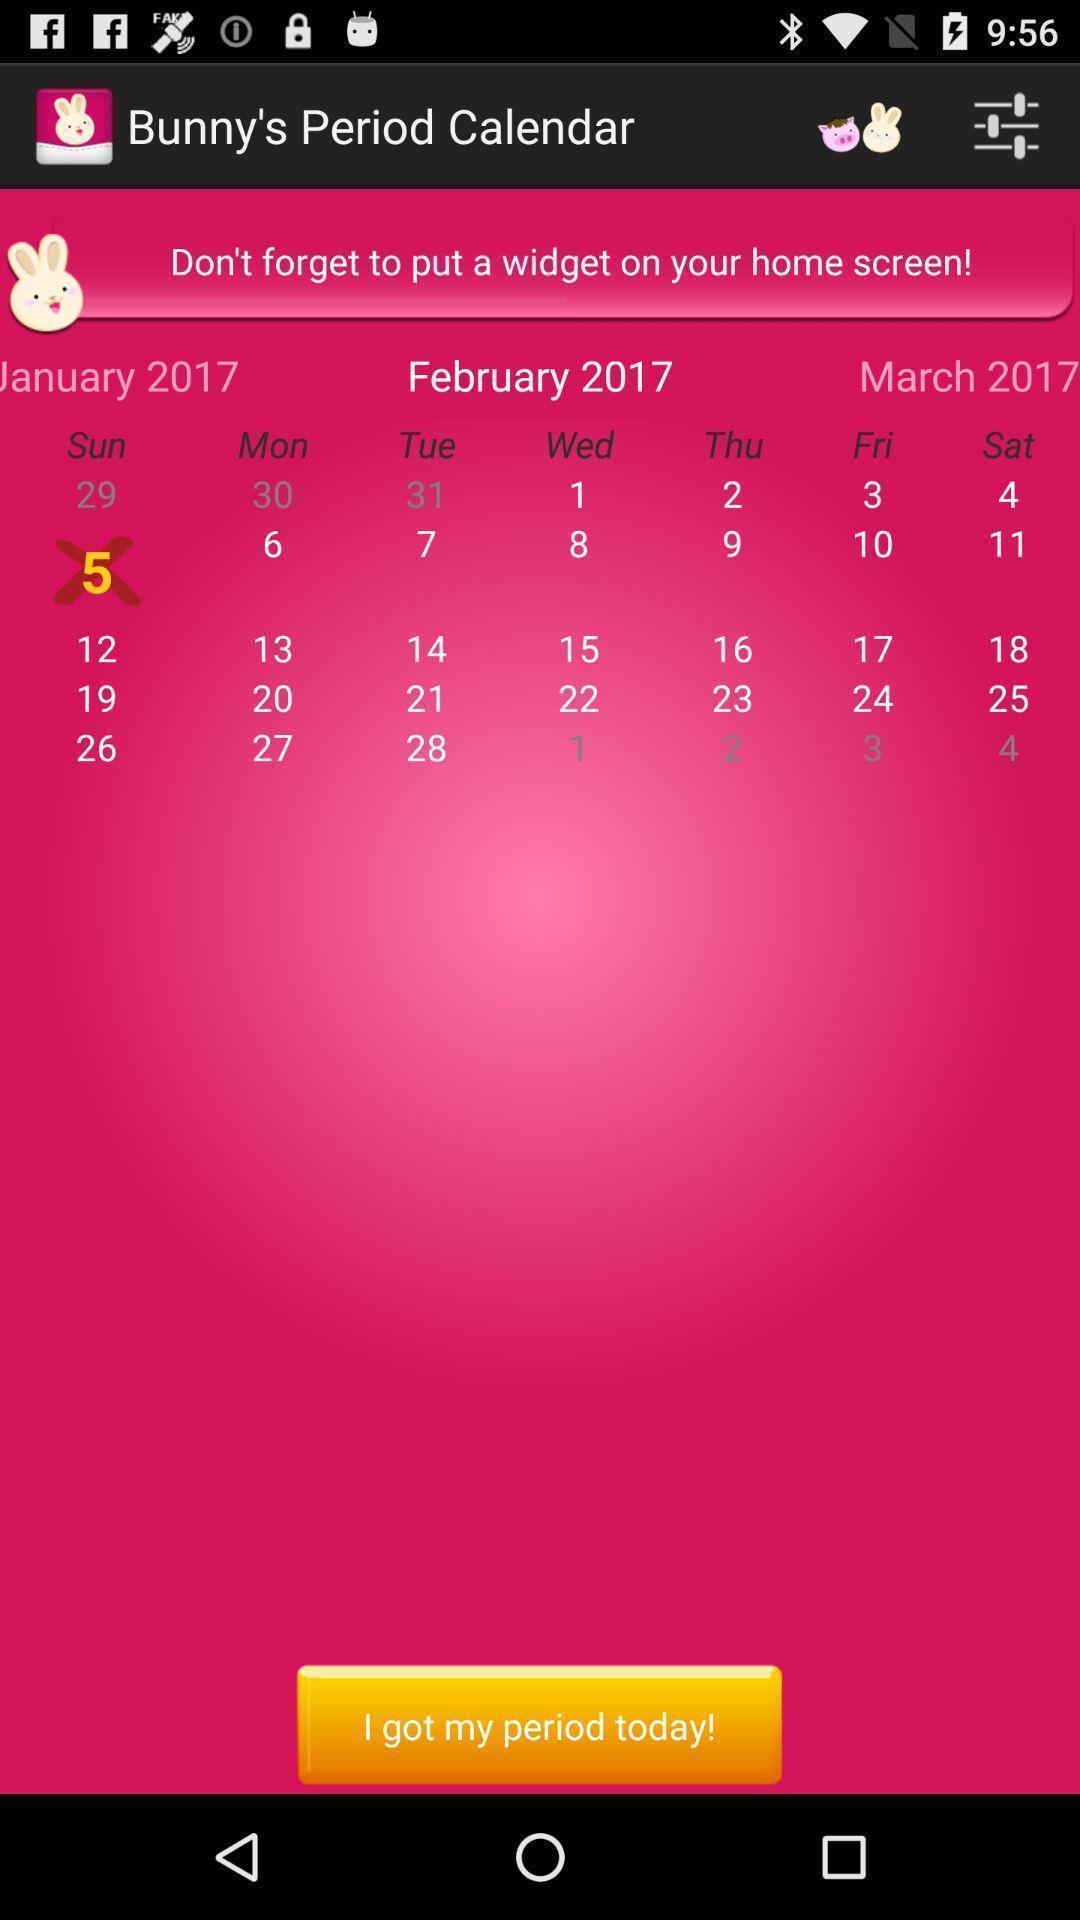Summarize the main components in this picture. Screen displaying about period calendar. 